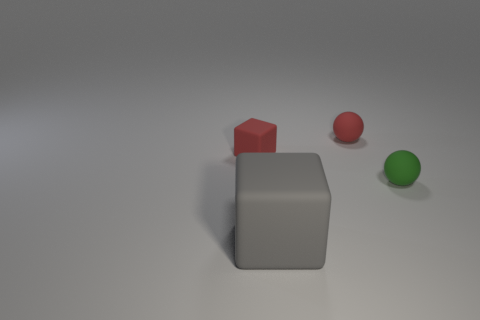Is there a purple metallic cube that has the same size as the red rubber cube?
Give a very brief answer. No. What is the tiny red thing on the left side of the big gray matte object made of?
Your answer should be compact. Rubber. Does the object on the left side of the large gray object have the same material as the small green thing?
Keep it short and to the point. Yes. Is there a big object?
Provide a short and direct response. Yes. There is a tiny sphere that is the same material as the green thing; what is its color?
Ensure brevity in your answer.  Red. What color is the thing that is right of the matte thing that is behind the small matte thing on the left side of the gray object?
Your answer should be compact. Green. There is a gray matte thing; does it have the same size as the sphere that is behind the tiny green sphere?
Offer a very short reply. No. How many objects are either tiny rubber spheres that are behind the green matte thing or red things that are to the left of the red rubber ball?
Ensure brevity in your answer.  2. What shape is the green object that is the same size as the red block?
Your answer should be very brief. Sphere. There is a thing that is in front of the tiny matte sphere in front of the small rubber thing on the left side of the large rubber object; what is its shape?
Give a very brief answer. Cube. 